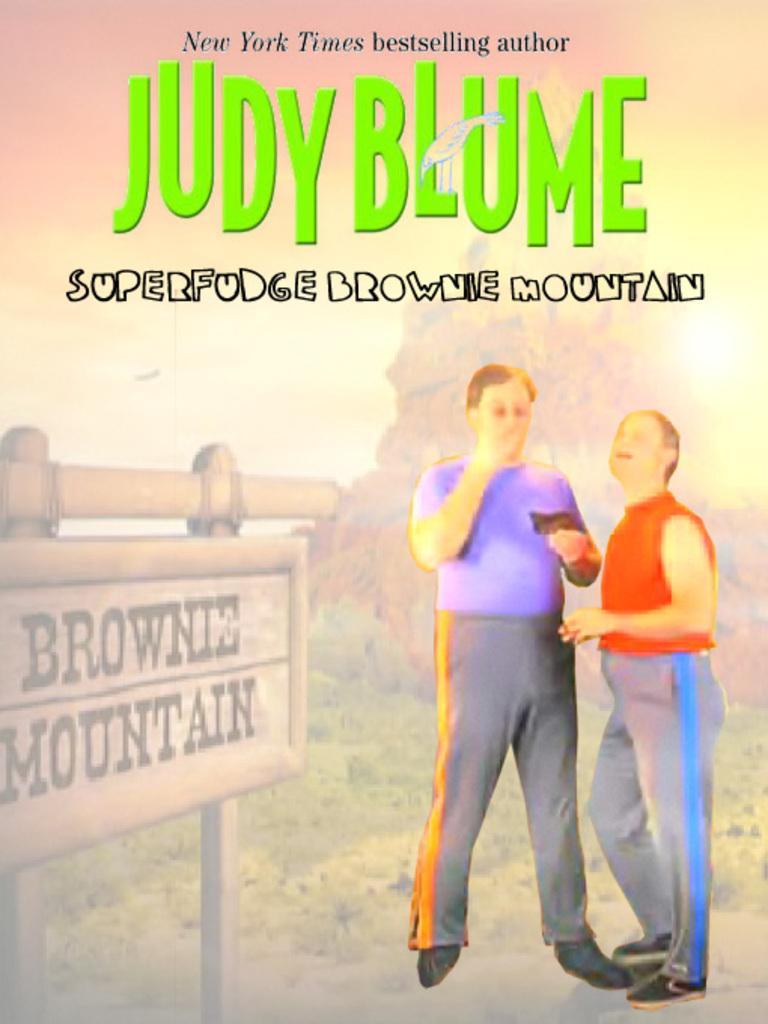Describe this image in one or two sentences. As we can see in the image there is a banner. On banner there is a sign board, grass and two people standing in the front. In the background there are trees and there is some matter. 